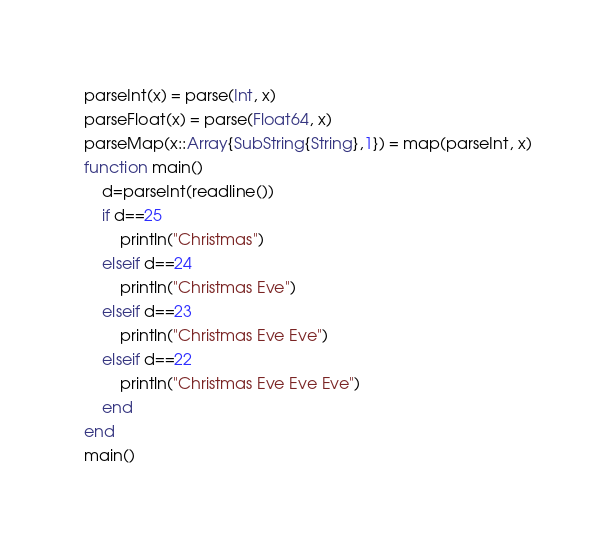<code> <loc_0><loc_0><loc_500><loc_500><_Julia_>parseInt(x) = parse(Int, x)
parseFloat(x) = parse(Float64, x)
parseMap(x::Array{SubString{String},1}) = map(parseInt, x)
function main()
    d=parseInt(readline())
    if d==25
        println("Christmas")
    elseif d==24
        println("Christmas Eve")
    elseif d==23
        println("Christmas Eve Eve")
    elseif d==22
        println("Christmas Eve Eve Eve")
    end
end
main()</code> 